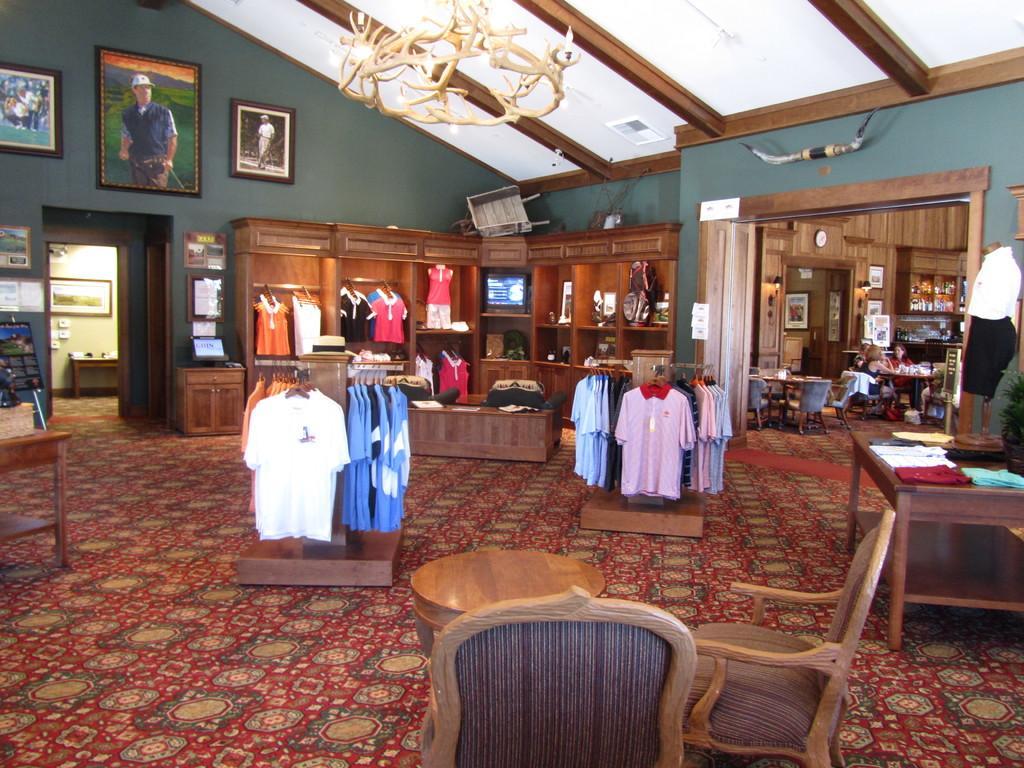Describe this image in one or two sentences. In picture we can see couple of chairs, tables clothes, a monitor in the room, and also we can see couple of photo frames on the wall, in the background we can find few people are seated on the chair. 